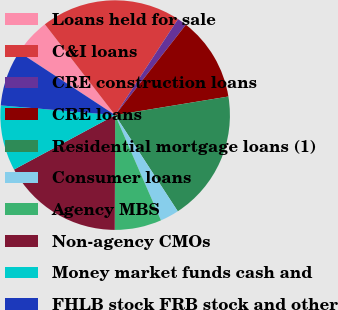Convert chart. <chart><loc_0><loc_0><loc_500><loc_500><pie_chart><fcel>Loans held for sale<fcel>C&I loans<fcel>CRE construction loans<fcel>CRE loans<fcel>Residential mortgage loans (1)<fcel>Consumer loans<fcel>Agency MBS<fcel>Non-agency CMOs<fcel>Money market funds cash and<fcel>FHLB stock FRB stock and other<nl><fcel>5.27%<fcel>19.72%<fcel>1.34%<fcel>11.84%<fcel>18.4%<fcel>2.65%<fcel>6.59%<fcel>17.09%<fcel>9.21%<fcel>7.9%<nl></chart> 